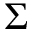<formula> <loc_0><loc_0><loc_500><loc_500>\Sigma</formula> 